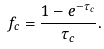Convert formula to latex. <formula><loc_0><loc_0><loc_500><loc_500>f _ { c } = \frac { 1 - e ^ { - \tau _ { c } } } { \tau _ { c } } .</formula> 